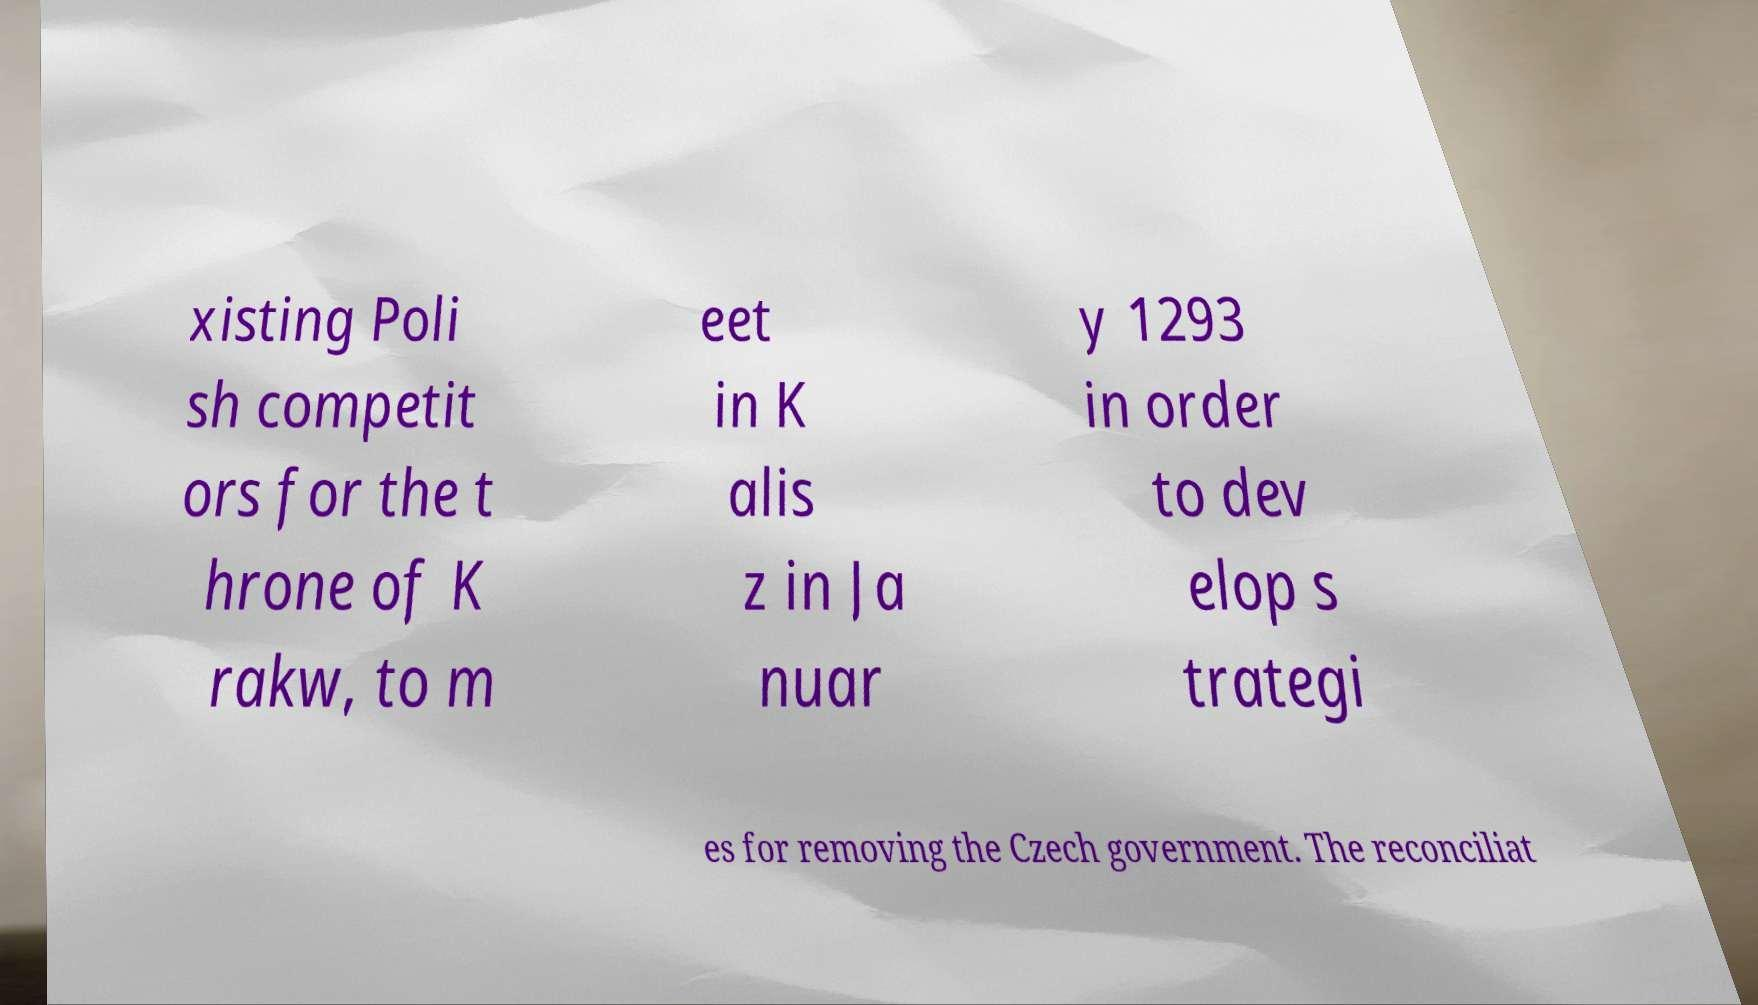Could you assist in decoding the text presented in this image and type it out clearly? xisting Poli sh competit ors for the t hrone of K rakw, to m eet in K alis z in Ja nuar y 1293 in order to dev elop s trategi es for removing the Czech government. The reconciliat 